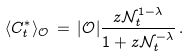Convert formula to latex. <formula><loc_0><loc_0><loc_500><loc_500>\langle C ^ { * } _ { t } \rangle _ { \mathcal { O } } \, = \, | { \mathcal { O } } | \frac { z { \mathcal { N } } _ { t } ^ { 1 - \lambda } } { 1 + z { \mathcal { N } } _ { t } ^ { - \lambda } } \, .</formula> 